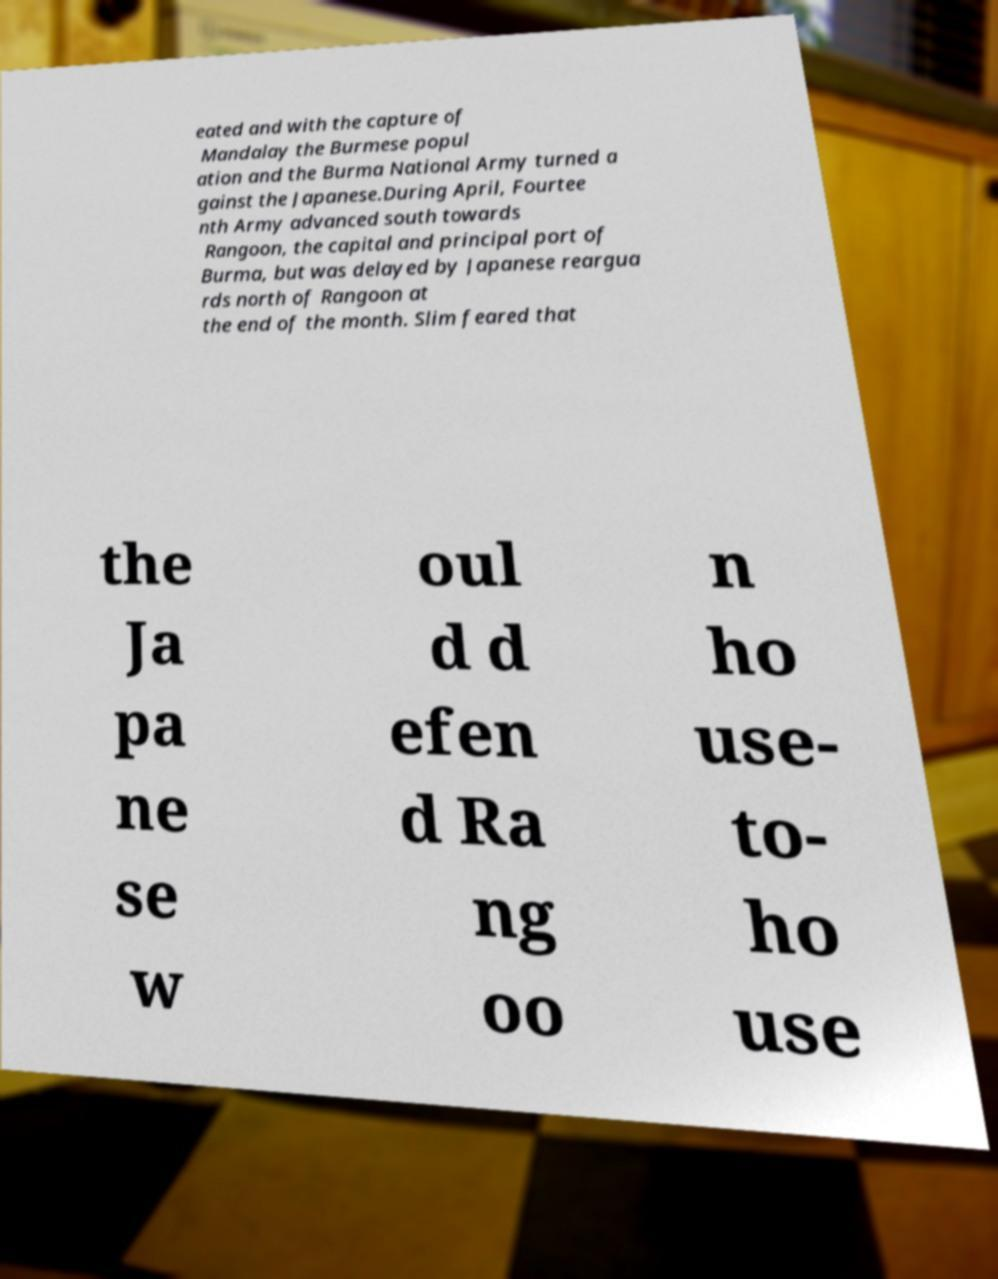For documentation purposes, I need the text within this image transcribed. Could you provide that? eated and with the capture of Mandalay the Burmese popul ation and the Burma National Army turned a gainst the Japanese.During April, Fourtee nth Army advanced south towards Rangoon, the capital and principal port of Burma, but was delayed by Japanese reargua rds north of Rangoon at the end of the month. Slim feared that the Ja pa ne se w oul d d efen d Ra ng oo n ho use- to- ho use 